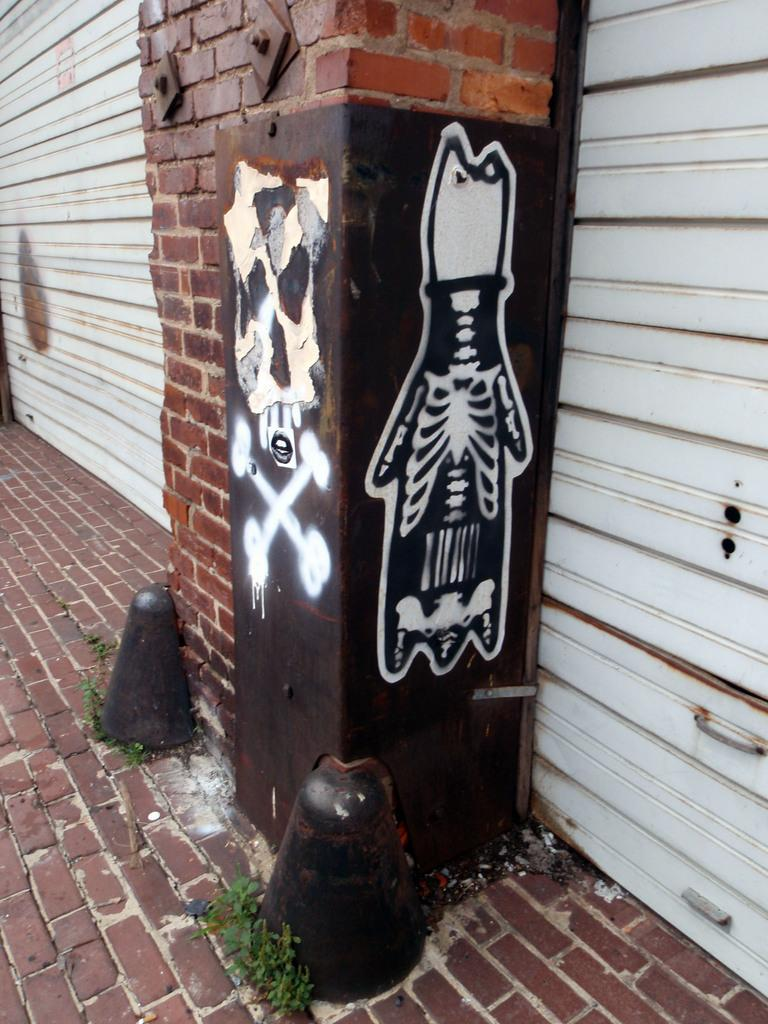What type of window covering is visible in the image? There are shutters in the image. What can be seen on a metal object in the image? There is a painting on a metal object in the image. What type of vegetation is present in the image? There are plants in the image. What architectural feature can be seen in the image? There is a pillar in the image. What class is being taught in the image? There is no class or teaching activity depicted in the image. What is the condition of the chin of the person in the image? There is no person present in the image, so it is not possible to determine the condition of their chin. 